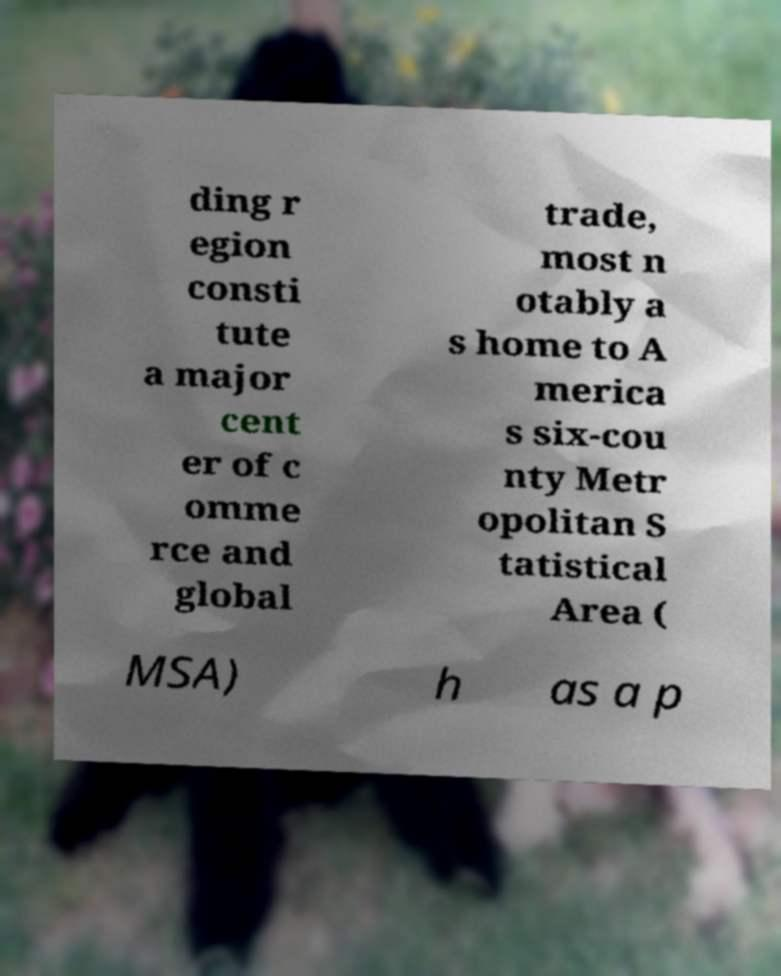Can you accurately transcribe the text from the provided image for me? ding r egion consti tute a major cent er of c omme rce and global trade, most n otably a s home to A merica s six-cou nty Metr opolitan S tatistical Area ( MSA) h as a p 